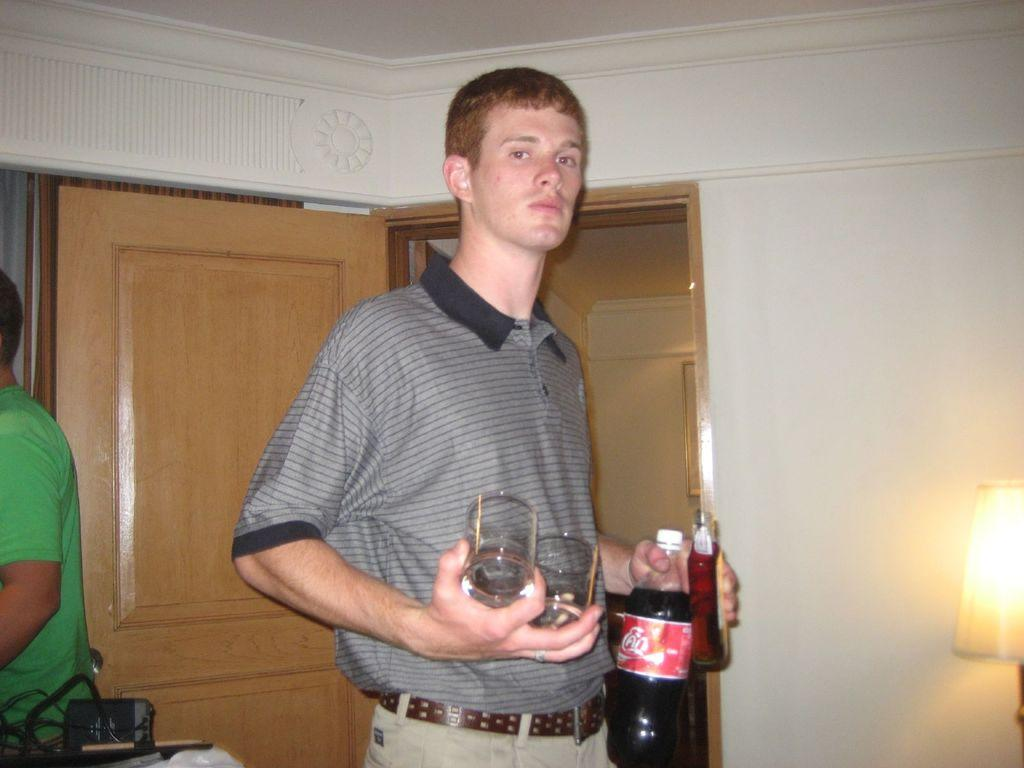What is the color of the wall in the image? The wall in the image is white. What object can be seen in the image that provides light? There is a lamp in the image. How many people are present in the image? There are two people standing in the image. What is one of the people holding in their hands? One of the people is holding a bottle and glasses. What type of grain is being harvested by the son in the image? There is no son or grain present in the image. How much dirt can be seen on the floor in the image? There is no dirt visible on the floor in the image. 